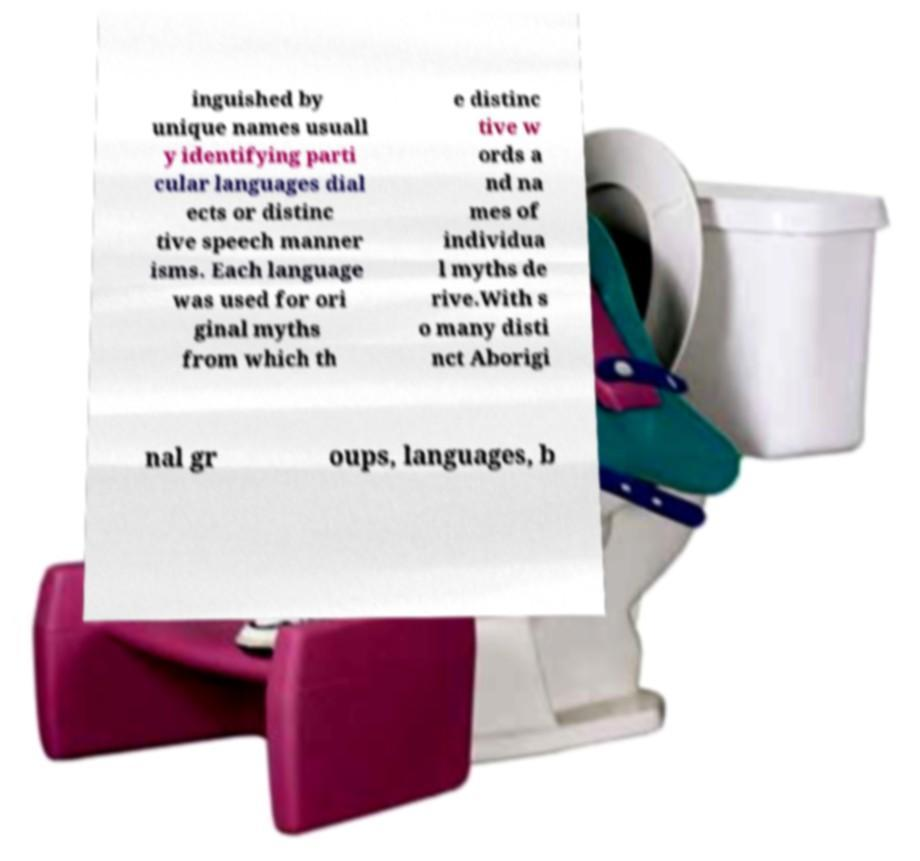Can you read and provide the text displayed in the image?This photo seems to have some interesting text. Can you extract and type it out for me? inguished by unique names usuall y identifying parti cular languages dial ects or distinc tive speech manner isms. Each language was used for ori ginal myths from which th e distinc tive w ords a nd na mes of individua l myths de rive.With s o many disti nct Aborigi nal gr oups, languages, b 